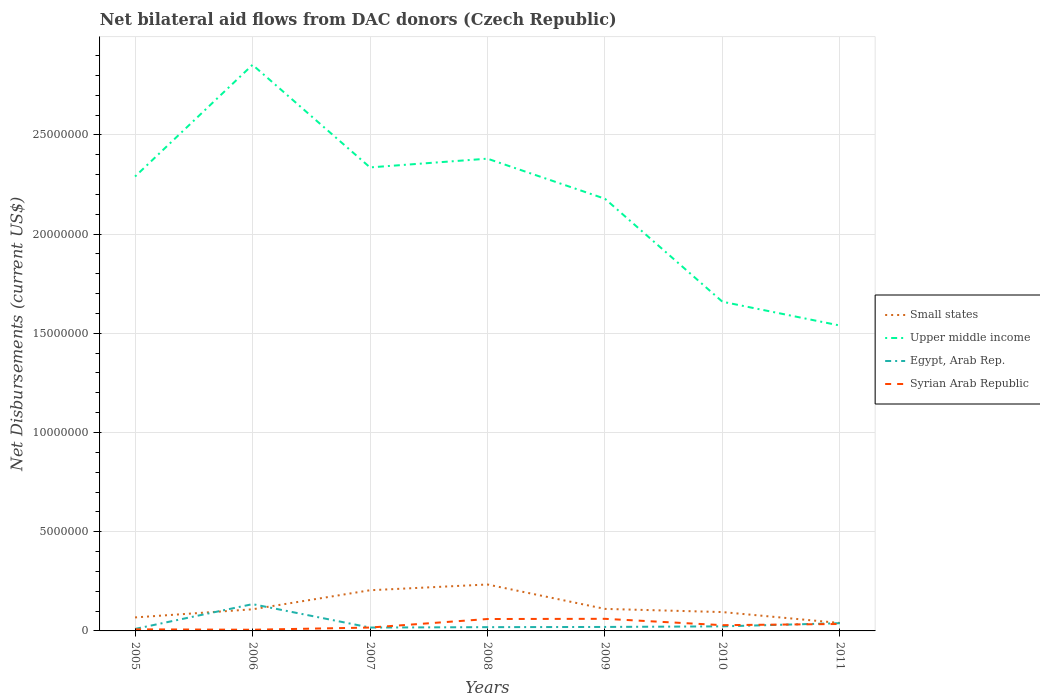Is the number of lines equal to the number of legend labels?
Ensure brevity in your answer.  Yes. Across all years, what is the maximum net bilateral aid flows in Upper middle income?
Give a very brief answer. 1.54e+07. What is the total net bilateral aid flows in Syrian Arab Republic in the graph?
Provide a short and direct response. -1.10e+05. What is the difference between the highest and the second highest net bilateral aid flows in Small states?
Your answer should be very brief. 1.94e+06. What is the difference between the highest and the lowest net bilateral aid flows in Egypt, Arab Rep.?
Keep it short and to the point. 2. Is the net bilateral aid flows in Syrian Arab Republic strictly greater than the net bilateral aid flows in Egypt, Arab Rep. over the years?
Keep it short and to the point. No. How many lines are there?
Offer a very short reply. 4. What is the difference between two consecutive major ticks on the Y-axis?
Offer a very short reply. 5.00e+06. Does the graph contain any zero values?
Your response must be concise. No. Does the graph contain grids?
Ensure brevity in your answer.  Yes. Where does the legend appear in the graph?
Give a very brief answer. Center right. How many legend labels are there?
Give a very brief answer. 4. What is the title of the graph?
Offer a very short reply. Net bilateral aid flows from DAC donors (Czech Republic). What is the label or title of the X-axis?
Provide a succinct answer. Years. What is the label or title of the Y-axis?
Your response must be concise. Net Disbursements (current US$). What is the Net Disbursements (current US$) of Small states in 2005?
Your answer should be compact. 6.80e+05. What is the Net Disbursements (current US$) of Upper middle income in 2005?
Offer a terse response. 2.29e+07. What is the Net Disbursements (current US$) of Syrian Arab Republic in 2005?
Offer a very short reply. 8.00e+04. What is the Net Disbursements (current US$) in Small states in 2006?
Offer a terse response. 1.09e+06. What is the Net Disbursements (current US$) of Upper middle income in 2006?
Your response must be concise. 2.85e+07. What is the Net Disbursements (current US$) in Egypt, Arab Rep. in 2006?
Your answer should be very brief. 1.35e+06. What is the Net Disbursements (current US$) of Small states in 2007?
Your answer should be very brief. 2.05e+06. What is the Net Disbursements (current US$) of Upper middle income in 2007?
Your answer should be very brief. 2.34e+07. What is the Net Disbursements (current US$) of Egypt, Arab Rep. in 2007?
Make the answer very short. 1.70e+05. What is the Net Disbursements (current US$) in Syrian Arab Republic in 2007?
Offer a very short reply. 1.70e+05. What is the Net Disbursements (current US$) in Small states in 2008?
Your answer should be very brief. 2.34e+06. What is the Net Disbursements (current US$) of Upper middle income in 2008?
Your answer should be compact. 2.38e+07. What is the Net Disbursements (current US$) in Syrian Arab Republic in 2008?
Your answer should be very brief. 6.00e+05. What is the Net Disbursements (current US$) of Small states in 2009?
Offer a terse response. 1.11e+06. What is the Net Disbursements (current US$) of Upper middle income in 2009?
Offer a very short reply. 2.18e+07. What is the Net Disbursements (current US$) of Egypt, Arab Rep. in 2009?
Your answer should be very brief. 2.00e+05. What is the Net Disbursements (current US$) in Small states in 2010?
Your response must be concise. 9.50e+05. What is the Net Disbursements (current US$) in Upper middle income in 2010?
Make the answer very short. 1.66e+07. What is the Net Disbursements (current US$) in Egypt, Arab Rep. in 2010?
Ensure brevity in your answer.  2.30e+05. What is the Net Disbursements (current US$) of Syrian Arab Republic in 2010?
Your answer should be very brief. 2.90e+05. What is the Net Disbursements (current US$) of Upper middle income in 2011?
Offer a very short reply. 1.54e+07. What is the Net Disbursements (current US$) of Egypt, Arab Rep. in 2011?
Keep it short and to the point. 3.90e+05. Across all years, what is the maximum Net Disbursements (current US$) in Small states?
Provide a short and direct response. 2.34e+06. Across all years, what is the maximum Net Disbursements (current US$) in Upper middle income?
Your answer should be compact. 2.85e+07. Across all years, what is the maximum Net Disbursements (current US$) in Egypt, Arab Rep.?
Provide a succinct answer. 1.35e+06. Across all years, what is the minimum Net Disbursements (current US$) in Upper middle income?
Provide a short and direct response. 1.54e+07. Across all years, what is the minimum Net Disbursements (current US$) in Syrian Arab Republic?
Offer a very short reply. 6.00e+04. What is the total Net Disbursements (current US$) in Small states in the graph?
Give a very brief answer. 8.62e+06. What is the total Net Disbursements (current US$) of Upper middle income in the graph?
Make the answer very short. 1.52e+08. What is the total Net Disbursements (current US$) of Egypt, Arab Rep. in the graph?
Offer a terse response. 2.63e+06. What is the total Net Disbursements (current US$) of Syrian Arab Republic in the graph?
Make the answer very short. 2.16e+06. What is the difference between the Net Disbursements (current US$) in Small states in 2005 and that in 2006?
Provide a short and direct response. -4.10e+05. What is the difference between the Net Disbursements (current US$) in Upper middle income in 2005 and that in 2006?
Your answer should be compact. -5.63e+06. What is the difference between the Net Disbursements (current US$) in Egypt, Arab Rep. in 2005 and that in 2006?
Offer a very short reply. -1.25e+06. What is the difference between the Net Disbursements (current US$) of Syrian Arab Republic in 2005 and that in 2006?
Ensure brevity in your answer.  2.00e+04. What is the difference between the Net Disbursements (current US$) of Small states in 2005 and that in 2007?
Provide a succinct answer. -1.37e+06. What is the difference between the Net Disbursements (current US$) of Upper middle income in 2005 and that in 2007?
Keep it short and to the point. -4.60e+05. What is the difference between the Net Disbursements (current US$) in Small states in 2005 and that in 2008?
Keep it short and to the point. -1.66e+06. What is the difference between the Net Disbursements (current US$) in Upper middle income in 2005 and that in 2008?
Give a very brief answer. -9.00e+05. What is the difference between the Net Disbursements (current US$) of Egypt, Arab Rep. in 2005 and that in 2008?
Keep it short and to the point. -9.00e+04. What is the difference between the Net Disbursements (current US$) of Syrian Arab Republic in 2005 and that in 2008?
Give a very brief answer. -5.20e+05. What is the difference between the Net Disbursements (current US$) of Small states in 2005 and that in 2009?
Provide a succinct answer. -4.30e+05. What is the difference between the Net Disbursements (current US$) of Upper middle income in 2005 and that in 2009?
Provide a succinct answer. 1.12e+06. What is the difference between the Net Disbursements (current US$) in Egypt, Arab Rep. in 2005 and that in 2009?
Ensure brevity in your answer.  -1.00e+05. What is the difference between the Net Disbursements (current US$) in Syrian Arab Republic in 2005 and that in 2009?
Offer a very short reply. -5.30e+05. What is the difference between the Net Disbursements (current US$) of Small states in 2005 and that in 2010?
Your response must be concise. -2.70e+05. What is the difference between the Net Disbursements (current US$) of Upper middle income in 2005 and that in 2010?
Make the answer very short. 6.31e+06. What is the difference between the Net Disbursements (current US$) in Upper middle income in 2005 and that in 2011?
Your answer should be compact. 7.51e+06. What is the difference between the Net Disbursements (current US$) in Egypt, Arab Rep. in 2005 and that in 2011?
Give a very brief answer. -2.90e+05. What is the difference between the Net Disbursements (current US$) of Syrian Arab Republic in 2005 and that in 2011?
Your answer should be very brief. -2.70e+05. What is the difference between the Net Disbursements (current US$) of Small states in 2006 and that in 2007?
Make the answer very short. -9.60e+05. What is the difference between the Net Disbursements (current US$) in Upper middle income in 2006 and that in 2007?
Provide a short and direct response. 5.17e+06. What is the difference between the Net Disbursements (current US$) in Egypt, Arab Rep. in 2006 and that in 2007?
Offer a very short reply. 1.18e+06. What is the difference between the Net Disbursements (current US$) of Small states in 2006 and that in 2008?
Provide a short and direct response. -1.25e+06. What is the difference between the Net Disbursements (current US$) in Upper middle income in 2006 and that in 2008?
Offer a very short reply. 4.73e+06. What is the difference between the Net Disbursements (current US$) of Egypt, Arab Rep. in 2006 and that in 2008?
Keep it short and to the point. 1.16e+06. What is the difference between the Net Disbursements (current US$) of Syrian Arab Republic in 2006 and that in 2008?
Provide a succinct answer. -5.40e+05. What is the difference between the Net Disbursements (current US$) in Small states in 2006 and that in 2009?
Your answer should be very brief. -2.00e+04. What is the difference between the Net Disbursements (current US$) of Upper middle income in 2006 and that in 2009?
Ensure brevity in your answer.  6.75e+06. What is the difference between the Net Disbursements (current US$) of Egypt, Arab Rep. in 2006 and that in 2009?
Offer a terse response. 1.15e+06. What is the difference between the Net Disbursements (current US$) of Syrian Arab Republic in 2006 and that in 2009?
Your answer should be compact. -5.50e+05. What is the difference between the Net Disbursements (current US$) in Small states in 2006 and that in 2010?
Your answer should be very brief. 1.40e+05. What is the difference between the Net Disbursements (current US$) in Upper middle income in 2006 and that in 2010?
Your response must be concise. 1.19e+07. What is the difference between the Net Disbursements (current US$) in Egypt, Arab Rep. in 2006 and that in 2010?
Provide a short and direct response. 1.12e+06. What is the difference between the Net Disbursements (current US$) of Syrian Arab Republic in 2006 and that in 2010?
Offer a very short reply. -2.30e+05. What is the difference between the Net Disbursements (current US$) in Small states in 2006 and that in 2011?
Offer a terse response. 6.90e+05. What is the difference between the Net Disbursements (current US$) in Upper middle income in 2006 and that in 2011?
Give a very brief answer. 1.31e+07. What is the difference between the Net Disbursements (current US$) of Egypt, Arab Rep. in 2006 and that in 2011?
Provide a short and direct response. 9.60e+05. What is the difference between the Net Disbursements (current US$) of Syrian Arab Republic in 2006 and that in 2011?
Your response must be concise. -2.90e+05. What is the difference between the Net Disbursements (current US$) of Small states in 2007 and that in 2008?
Keep it short and to the point. -2.90e+05. What is the difference between the Net Disbursements (current US$) in Upper middle income in 2007 and that in 2008?
Ensure brevity in your answer.  -4.40e+05. What is the difference between the Net Disbursements (current US$) of Syrian Arab Republic in 2007 and that in 2008?
Keep it short and to the point. -4.30e+05. What is the difference between the Net Disbursements (current US$) of Small states in 2007 and that in 2009?
Make the answer very short. 9.40e+05. What is the difference between the Net Disbursements (current US$) in Upper middle income in 2007 and that in 2009?
Your response must be concise. 1.58e+06. What is the difference between the Net Disbursements (current US$) in Egypt, Arab Rep. in 2007 and that in 2009?
Provide a succinct answer. -3.00e+04. What is the difference between the Net Disbursements (current US$) in Syrian Arab Republic in 2007 and that in 2009?
Make the answer very short. -4.40e+05. What is the difference between the Net Disbursements (current US$) in Small states in 2007 and that in 2010?
Give a very brief answer. 1.10e+06. What is the difference between the Net Disbursements (current US$) in Upper middle income in 2007 and that in 2010?
Keep it short and to the point. 6.77e+06. What is the difference between the Net Disbursements (current US$) of Egypt, Arab Rep. in 2007 and that in 2010?
Keep it short and to the point. -6.00e+04. What is the difference between the Net Disbursements (current US$) of Small states in 2007 and that in 2011?
Provide a short and direct response. 1.65e+06. What is the difference between the Net Disbursements (current US$) of Upper middle income in 2007 and that in 2011?
Your answer should be compact. 7.97e+06. What is the difference between the Net Disbursements (current US$) in Egypt, Arab Rep. in 2007 and that in 2011?
Keep it short and to the point. -2.20e+05. What is the difference between the Net Disbursements (current US$) of Syrian Arab Republic in 2007 and that in 2011?
Ensure brevity in your answer.  -1.80e+05. What is the difference between the Net Disbursements (current US$) in Small states in 2008 and that in 2009?
Give a very brief answer. 1.23e+06. What is the difference between the Net Disbursements (current US$) in Upper middle income in 2008 and that in 2009?
Your answer should be very brief. 2.02e+06. What is the difference between the Net Disbursements (current US$) of Syrian Arab Republic in 2008 and that in 2009?
Your answer should be very brief. -10000. What is the difference between the Net Disbursements (current US$) of Small states in 2008 and that in 2010?
Your answer should be very brief. 1.39e+06. What is the difference between the Net Disbursements (current US$) in Upper middle income in 2008 and that in 2010?
Your response must be concise. 7.21e+06. What is the difference between the Net Disbursements (current US$) of Egypt, Arab Rep. in 2008 and that in 2010?
Give a very brief answer. -4.00e+04. What is the difference between the Net Disbursements (current US$) in Small states in 2008 and that in 2011?
Your answer should be compact. 1.94e+06. What is the difference between the Net Disbursements (current US$) in Upper middle income in 2008 and that in 2011?
Provide a short and direct response. 8.41e+06. What is the difference between the Net Disbursements (current US$) in Upper middle income in 2009 and that in 2010?
Give a very brief answer. 5.19e+06. What is the difference between the Net Disbursements (current US$) of Small states in 2009 and that in 2011?
Provide a succinct answer. 7.10e+05. What is the difference between the Net Disbursements (current US$) in Upper middle income in 2009 and that in 2011?
Your answer should be very brief. 6.39e+06. What is the difference between the Net Disbursements (current US$) in Small states in 2010 and that in 2011?
Your answer should be compact. 5.50e+05. What is the difference between the Net Disbursements (current US$) of Upper middle income in 2010 and that in 2011?
Give a very brief answer. 1.20e+06. What is the difference between the Net Disbursements (current US$) in Small states in 2005 and the Net Disbursements (current US$) in Upper middle income in 2006?
Provide a short and direct response. -2.78e+07. What is the difference between the Net Disbursements (current US$) in Small states in 2005 and the Net Disbursements (current US$) in Egypt, Arab Rep. in 2006?
Make the answer very short. -6.70e+05. What is the difference between the Net Disbursements (current US$) of Small states in 2005 and the Net Disbursements (current US$) of Syrian Arab Republic in 2006?
Make the answer very short. 6.20e+05. What is the difference between the Net Disbursements (current US$) in Upper middle income in 2005 and the Net Disbursements (current US$) in Egypt, Arab Rep. in 2006?
Your answer should be compact. 2.16e+07. What is the difference between the Net Disbursements (current US$) in Upper middle income in 2005 and the Net Disbursements (current US$) in Syrian Arab Republic in 2006?
Offer a terse response. 2.28e+07. What is the difference between the Net Disbursements (current US$) in Egypt, Arab Rep. in 2005 and the Net Disbursements (current US$) in Syrian Arab Republic in 2006?
Offer a terse response. 4.00e+04. What is the difference between the Net Disbursements (current US$) of Small states in 2005 and the Net Disbursements (current US$) of Upper middle income in 2007?
Provide a short and direct response. -2.27e+07. What is the difference between the Net Disbursements (current US$) of Small states in 2005 and the Net Disbursements (current US$) of Egypt, Arab Rep. in 2007?
Your answer should be very brief. 5.10e+05. What is the difference between the Net Disbursements (current US$) in Small states in 2005 and the Net Disbursements (current US$) in Syrian Arab Republic in 2007?
Ensure brevity in your answer.  5.10e+05. What is the difference between the Net Disbursements (current US$) of Upper middle income in 2005 and the Net Disbursements (current US$) of Egypt, Arab Rep. in 2007?
Your answer should be compact. 2.27e+07. What is the difference between the Net Disbursements (current US$) of Upper middle income in 2005 and the Net Disbursements (current US$) of Syrian Arab Republic in 2007?
Give a very brief answer. 2.27e+07. What is the difference between the Net Disbursements (current US$) of Egypt, Arab Rep. in 2005 and the Net Disbursements (current US$) of Syrian Arab Republic in 2007?
Give a very brief answer. -7.00e+04. What is the difference between the Net Disbursements (current US$) of Small states in 2005 and the Net Disbursements (current US$) of Upper middle income in 2008?
Make the answer very short. -2.31e+07. What is the difference between the Net Disbursements (current US$) of Small states in 2005 and the Net Disbursements (current US$) of Egypt, Arab Rep. in 2008?
Keep it short and to the point. 4.90e+05. What is the difference between the Net Disbursements (current US$) in Upper middle income in 2005 and the Net Disbursements (current US$) in Egypt, Arab Rep. in 2008?
Ensure brevity in your answer.  2.27e+07. What is the difference between the Net Disbursements (current US$) in Upper middle income in 2005 and the Net Disbursements (current US$) in Syrian Arab Republic in 2008?
Provide a succinct answer. 2.23e+07. What is the difference between the Net Disbursements (current US$) of Egypt, Arab Rep. in 2005 and the Net Disbursements (current US$) of Syrian Arab Republic in 2008?
Make the answer very short. -5.00e+05. What is the difference between the Net Disbursements (current US$) in Small states in 2005 and the Net Disbursements (current US$) in Upper middle income in 2009?
Offer a terse response. -2.11e+07. What is the difference between the Net Disbursements (current US$) in Small states in 2005 and the Net Disbursements (current US$) in Syrian Arab Republic in 2009?
Provide a short and direct response. 7.00e+04. What is the difference between the Net Disbursements (current US$) in Upper middle income in 2005 and the Net Disbursements (current US$) in Egypt, Arab Rep. in 2009?
Give a very brief answer. 2.27e+07. What is the difference between the Net Disbursements (current US$) of Upper middle income in 2005 and the Net Disbursements (current US$) of Syrian Arab Republic in 2009?
Provide a succinct answer. 2.23e+07. What is the difference between the Net Disbursements (current US$) in Egypt, Arab Rep. in 2005 and the Net Disbursements (current US$) in Syrian Arab Republic in 2009?
Offer a very short reply. -5.10e+05. What is the difference between the Net Disbursements (current US$) in Small states in 2005 and the Net Disbursements (current US$) in Upper middle income in 2010?
Offer a very short reply. -1.59e+07. What is the difference between the Net Disbursements (current US$) of Upper middle income in 2005 and the Net Disbursements (current US$) of Egypt, Arab Rep. in 2010?
Offer a very short reply. 2.27e+07. What is the difference between the Net Disbursements (current US$) in Upper middle income in 2005 and the Net Disbursements (current US$) in Syrian Arab Republic in 2010?
Make the answer very short. 2.26e+07. What is the difference between the Net Disbursements (current US$) in Small states in 2005 and the Net Disbursements (current US$) in Upper middle income in 2011?
Provide a succinct answer. -1.47e+07. What is the difference between the Net Disbursements (current US$) of Small states in 2005 and the Net Disbursements (current US$) of Egypt, Arab Rep. in 2011?
Provide a succinct answer. 2.90e+05. What is the difference between the Net Disbursements (current US$) in Small states in 2005 and the Net Disbursements (current US$) in Syrian Arab Republic in 2011?
Your response must be concise. 3.30e+05. What is the difference between the Net Disbursements (current US$) of Upper middle income in 2005 and the Net Disbursements (current US$) of Egypt, Arab Rep. in 2011?
Offer a terse response. 2.25e+07. What is the difference between the Net Disbursements (current US$) in Upper middle income in 2005 and the Net Disbursements (current US$) in Syrian Arab Republic in 2011?
Your response must be concise. 2.26e+07. What is the difference between the Net Disbursements (current US$) in Egypt, Arab Rep. in 2005 and the Net Disbursements (current US$) in Syrian Arab Republic in 2011?
Provide a succinct answer. -2.50e+05. What is the difference between the Net Disbursements (current US$) of Small states in 2006 and the Net Disbursements (current US$) of Upper middle income in 2007?
Make the answer very short. -2.23e+07. What is the difference between the Net Disbursements (current US$) in Small states in 2006 and the Net Disbursements (current US$) in Egypt, Arab Rep. in 2007?
Give a very brief answer. 9.20e+05. What is the difference between the Net Disbursements (current US$) in Small states in 2006 and the Net Disbursements (current US$) in Syrian Arab Republic in 2007?
Give a very brief answer. 9.20e+05. What is the difference between the Net Disbursements (current US$) of Upper middle income in 2006 and the Net Disbursements (current US$) of Egypt, Arab Rep. in 2007?
Provide a succinct answer. 2.84e+07. What is the difference between the Net Disbursements (current US$) of Upper middle income in 2006 and the Net Disbursements (current US$) of Syrian Arab Republic in 2007?
Offer a very short reply. 2.84e+07. What is the difference between the Net Disbursements (current US$) of Egypt, Arab Rep. in 2006 and the Net Disbursements (current US$) of Syrian Arab Republic in 2007?
Your answer should be compact. 1.18e+06. What is the difference between the Net Disbursements (current US$) in Small states in 2006 and the Net Disbursements (current US$) in Upper middle income in 2008?
Your answer should be compact. -2.27e+07. What is the difference between the Net Disbursements (current US$) in Small states in 2006 and the Net Disbursements (current US$) in Egypt, Arab Rep. in 2008?
Keep it short and to the point. 9.00e+05. What is the difference between the Net Disbursements (current US$) of Upper middle income in 2006 and the Net Disbursements (current US$) of Egypt, Arab Rep. in 2008?
Your answer should be compact. 2.83e+07. What is the difference between the Net Disbursements (current US$) in Upper middle income in 2006 and the Net Disbursements (current US$) in Syrian Arab Republic in 2008?
Provide a short and direct response. 2.79e+07. What is the difference between the Net Disbursements (current US$) in Egypt, Arab Rep. in 2006 and the Net Disbursements (current US$) in Syrian Arab Republic in 2008?
Give a very brief answer. 7.50e+05. What is the difference between the Net Disbursements (current US$) of Small states in 2006 and the Net Disbursements (current US$) of Upper middle income in 2009?
Your answer should be compact. -2.07e+07. What is the difference between the Net Disbursements (current US$) in Small states in 2006 and the Net Disbursements (current US$) in Egypt, Arab Rep. in 2009?
Give a very brief answer. 8.90e+05. What is the difference between the Net Disbursements (current US$) in Upper middle income in 2006 and the Net Disbursements (current US$) in Egypt, Arab Rep. in 2009?
Provide a succinct answer. 2.83e+07. What is the difference between the Net Disbursements (current US$) of Upper middle income in 2006 and the Net Disbursements (current US$) of Syrian Arab Republic in 2009?
Give a very brief answer. 2.79e+07. What is the difference between the Net Disbursements (current US$) of Egypt, Arab Rep. in 2006 and the Net Disbursements (current US$) of Syrian Arab Republic in 2009?
Give a very brief answer. 7.40e+05. What is the difference between the Net Disbursements (current US$) in Small states in 2006 and the Net Disbursements (current US$) in Upper middle income in 2010?
Provide a succinct answer. -1.55e+07. What is the difference between the Net Disbursements (current US$) in Small states in 2006 and the Net Disbursements (current US$) in Egypt, Arab Rep. in 2010?
Ensure brevity in your answer.  8.60e+05. What is the difference between the Net Disbursements (current US$) in Upper middle income in 2006 and the Net Disbursements (current US$) in Egypt, Arab Rep. in 2010?
Give a very brief answer. 2.83e+07. What is the difference between the Net Disbursements (current US$) in Upper middle income in 2006 and the Net Disbursements (current US$) in Syrian Arab Republic in 2010?
Your answer should be compact. 2.82e+07. What is the difference between the Net Disbursements (current US$) of Egypt, Arab Rep. in 2006 and the Net Disbursements (current US$) of Syrian Arab Republic in 2010?
Keep it short and to the point. 1.06e+06. What is the difference between the Net Disbursements (current US$) of Small states in 2006 and the Net Disbursements (current US$) of Upper middle income in 2011?
Keep it short and to the point. -1.43e+07. What is the difference between the Net Disbursements (current US$) in Small states in 2006 and the Net Disbursements (current US$) in Syrian Arab Republic in 2011?
Make the answer very short. 7.40e+05. What is the difference between the Net Disbursements (current US$) of Upper middle income in 2006 and the Net Disbursements (current US$) of Egypt, Arab Rep. in 2011?
Ensure brevity in your answer.  2.81e+07. What is the difference between the Net Disbursements (current US$) of Upper middle income in 2006 and the Net Disbursements (current US$) of Syrian Arab Republic in 2011?
Your answer should be very brief. 2.82e+07. What is the difference between the Net Disbursements (current US$) in Small states in 2007 and the Net Disbursements (current US$) in Upper middle income in 2008?
Provide a short and direct response. -2.18e+07. What is the difference between the Net Disbursements (current US$) of Small states in 2007 and the Net Disbursements (current US$) of Egypt, Arab Rep. in 2008?
Ensure brevity in your answer.  1.86e+06. What is the difference between the Net Disbursements (current US$) of Small states in 2007 and the Net Disbursements (current US$) of Syrian Arab Republic in 2008?
Offer a terse response. 1.45e+06. What is the difference between the Net Disbursements (current US$) in Upper middle income in 2007 and the Net Disbursements (current US$) in Egypt, Arab Rep. in 2008?
Provide a short and direct response. 2.32e+07. What is the difference between the Net Disbursements (current US$) of Upper middle income in 2007 and the Net Disbursements (current US$) of Syrian Arab Republic in 2008?
Make the answer very short. 2.28e+07. What is the difference between the Net Disbursements (current US$) in Egypt, Arab Rep. in 2007 and the Net Disbursements (current US$) in Syrian Arab Republic in 2008?
Keep it short and to the point. -4.30e+05. What is the difference between the Net Disbursements (current US$) in Small states in 2007 and the Net Disbursements (current US$) in Upper middle income in 2009?
Make the answer very short. -1.97e+07. What is the difference between the Net Disbursements (current US$) of Small states in 2007 and the Net Disbursements (current US$) of Egypt, Arab Rep. in 2009?
Your response must be concise. 1.85e+06. What is the difference between the Net Disbursements (current US$) in Small states in 2007 and the Net Disbursements (current US$) in Syrian Arab Republic in 2009?
Offer a very short reply. 1.44e+06. What is the difference between the Net Disbursements (current US$) in Upper middle income in 2007 and the Net Disbursements (current US$) in Egypt, Arab Rep. in 2009?
Provide a succinct answer. 2.32e+07. What is the difference between the Net Disbursements (current US$) in Upper middle income in 2007 and the Net Disbursements (current US$) in Syrian Arab Republic in 2009?
Your answer should be compact. 2.28e+07. What is the difference between the Net Disbursements (current US$) of Egypt, Arab Rep. in 2007 and the Net Disbursements (current US$) of Syrian Arab Republic in 2009?
Your response must be concise. -4.40e+05. What is the difference between the Net Disbursements (current US$) of Small states in 2007 and the Net Disbursements (current US$) of Upper middle income in 2010?
Offer a terse response. -1.45e+07. What is the difference between the Net Disbursements (current US$) of Small states in 2007 and the Net Disbursements (current US$) of Egypt, Arab Rep. in 2010?
Your response must be concise. 1.82e+06. What is the difference between the Net Disbursements (current US$) in Small states in 2007 and the Net Disbursements (current US$) in Syrian Arab Republic in 2010?
Provide a short and direct response. 1.76e+06. What is the difference between the Net Disbursements (current US$) of Upper middle income in 2007 and the Net Disbursements (current US$) of Egypt, Arab Rep. in 2010?
Offer a terse response. 2.31e+07. What is the difference between the Net Disbursements (current US$) in Upper middle income in 2007 and the Net Disbursements (current US$) in Syrian Arab Republic in 2010?
Give a very brief answer. 2.31e+07. What is the difference between the Net Disbursements (current US$) in Small states in 2007 and the Net Disbursements (current US$) in Upper middle income in 2011?
Keep it short and to the point. -1.33e+07. What is the difference between the Net Disbursements (current US$) of Small states in 2007 and the Net Disbursements (current US$) of Egypt, Arab Rep. in 2011?
Give a very brief answer. 1.66e+06. What is the difference between the Net Disbursements (current US$) in Small states in 2007 and the Net Disbursements (current US$) in Syrian Arab Republic in 2011?
Your answer should be compact. 1.70e+06. What is the difference between the Net Disbursements (current US$) in Upper middle income in 2007 and the Net Disbursements (current US$) in Egypt, Arab Rep. in 2011?
Provide a succinct answer. 2.30e+07. What is the difference between the Net Disbursements (current US$) of Upper middle income in 2007 and the Net Disbursements (current US$) of Syrian Arab Republic in 2011?
Offer a terse response. 2.30e+07. What is the difference between the Net Disbursements (current US$) of Egypt, Arab Rep. in 2007 and the Net Disbursements (current US$) of Syrian Arab Republic in 2011?
Provide a short and direct response. -1.80e+05. What is the difference between the Net Disbursements (current US$) in Small states in 2008 and the Net Disbursements (current US$) in Upper middle income in 2009?
Your answer should be compact. -1.94e+07. What is the difference between the Net Disbursements (current US$) in Small states in 2008 and the Net Disbursements (current US$) in Egypt, Arab Rep. in 2009?
Your answer should be very brief. 2.14e+06. What is the difference between the Net Disbursements (current US$) of Small states in 2008 and the Net Disbursements (current US$) of Syrian Arab Republic in 2009?
Offer a terse response. 1.73e+06. What is the difference between the Net Disbursements (current US$) in Upper middle income in 2008 and the Net Disbursements (current US$) in Egypt, Arab Rep. in 2009?
Offer a very short reply. 2.36e+07. What is the difference between the Net Disbursements (current US$) in Upper middle income in 2008 and the Net Disbursements (current US$) in Syrian Arab Republic in 2009?
Your response must be concise. 2.32e+07. What is the difference between the Net Disbursements (current US$) in Egypt, Arab Rep. in 2008 and the Net Disbursements (current US$) in Syrian Arab Republic in 2009?
Ensure brevity in your answer.  -4.20e+05. What is the difference between the Net Disbursements (current US$) of Small states in 2008 and the Net Disbursements (current US$) of Upper middle income in 2010?
Your answer should be very brief. -1.42e+07. What is the difference between the Net Disbursements (current US$) in Small states in 2008 and the Net Disbursements (current US$) in Egypt, Arab Rep. in 2010?
Your response must be concise. 2.11e+06. What is the difference between the Net Disbursements (current US$) in Small states in 2008 and the Net Disbursements (current US$) in Syrian Arab Republic in 2010?
Offer a very short reply. 2.05e+06. What is the difference between the Net Disbursements (current US$) in Upper middle income in 2008 and the Net Disbursements (current US$) in Egypt, Arab Rep. in 2010?
Provide a succinct answer. 2.36e+07. What is the difference between the Net Disbursements (current US$) in Upper middle income in 2008 and the Net Disbursements (current US$) in Syrian Arab Republic in 2010?
Ensure brevity in your answer.  2.35e+07. What is the difference between the Net Disbursements (current US$) in Small states in 2008 and the Net Disbursements (current US$) in Upper middle income in 2011?
Keep it short and to the point. -1.30e+07. What is the difference between the Net Disbursements (current US$) of Small states in 2008 and the Net Disbursements (current US$) of Egypt, Arab Rep. in 2011?
Give a very brief answer. 1.95e+06. What is the difference between the Net Disbursements (current US$) in Small states in 2008 and the Net Disbursements (current US$) in Syrian Arab Republic in 2011?
Offer a very short reply. 1.99e+06. What is the difference between the Net Disbursements (current US$) of Upper middle income in 2008 and the Net Disbursements (current US$) of Egypt, Arab Rep. in 2011?
Your answer should be compact. 2.34e+07. What is the difference between the Net Disbursements (current US$) in Upper middle income in 2008 and the Net Disbursements (current US$) in Syrian Arab Republic in 2011?
Your answer should be very brief. 2.34e+07. What is the difference between the Net Disbursements (current US$) of Egypt, Arab Rep. in 2008 and the Net Disbursements (current US$) of Syrian Arab Republic in 2011?
Give a very brief answer. -1.60e+05. What is the difference between the Net Disbursements (current US$) of Small states in 2009 and the Net Disbursements (current US$) of Upper middle income in 2010?
Your response must be concise. -1.55e+07. What is the difference between the Net Disbursements (current US$) of Small states in 2009 and the Net Disbursements (current US$) of Egypt, Arab Rep. in 2010?
Give a very brief answer. 8.80e+05. What is the difference between the Net Disbursements (current US$) in Small states in 2009 and the Net Disbursements (current US$) in Syrian Arab Republic in 2010?
Offer a very short reply. 8.20e+05. What is the difference between the Net Disbursements (current US$) of Upper middle income in 2009 and the Net Disbursements (current US$) of Egypt, Arab Rep. in 2010?
Make the answer very short. 2.16e+07. What is the difference between the Net Disbursements (current US$) of Upper middle income in 2009 and the Net Disbursements (current US$) of Syrian Arab Republic in 2010?
Provide a succinct answer. 2.15e+07. What is the difference between the Net Disbursements (current US$) of Egypt, Arab Rep. in 2009 and the Net Disbursements (current US$) of Syrian Arab Republic in 2010?
Your response must be concise. -9.00e+04. What is the difference between the Net Disbursements (current US$) of Small states in 2009 and the Net Disbursements (current US$) of Upper middle income in 2011?
Keep it short and to the point. -1.43e+07. What is the difference between the Net Disbursements (current US$) in Small states in 2009 and the Net Disbursements (current US$) in Egypt, Arab Rep. in 2011?
Give a very brief answer. 7.20e+05. What is the difference between the Net Disbursements (current US$) in Small states in 2009 and the Net Disbursements (current US$) in Syrian Arab Republic in 2011?
Give a very brief answer. 7.60e+05. What is the difference between the Net Disbursements (current US$) of Upper middle income in 2009 and the Net Disbursements (current US$) of Egypt, Arab Rep. in 2011?
Provide a succinct answer. 2.14e+07. What is the difference between the Net Disbursements (current US$) in Upper middle income in 2009 and the Net Disbursements (current US$) in Syrian Arab Republic in 2011?
Ensure brevity in your answer.  2.14e+07. What is the difference between the Net Disbursements (current US$) of Egypt, Arab Rep. in 2009 and the Net Disbursements (current US$) of Syrian Arab Republic in 2011?
Provide a short and direct response. -1.50e+05. What is the difference between the Net Disbursements (current US$) in Small states in 2010 and the Net Disbursements (current US$) in Upper middle income in 2011?
Your answer should be very brief. -1.44e+07. What is the difference between the Net Disbursements (current US$) of Small states in 2010 and the Net Disbursements (current US$) of Egypt, Arab Rep. in 2011?
Give a very brief answer. 5.60e+05. What is the difference between the Net Disbursements (current US$) of Small states in 2010 and the Net Disbursements (current US$) of Syrian Arab Republic in 2011?
Keep it short and to the point. 6.00e+05. What is the difference between the Net Disbursements (current US$) of Upper middle income in 2010 and the Net Disbursements (current US$) of Egypt, Arab Rep. in 2011?
Make the answer very short. 1.62e+07. What is the difference between the Net Disbursements (current US$) of Upper middle income in 2010 and the Net Disbursements (current US$) of Syrian Arab Republic in 2011?
Keep it short and to the point. 1.62e+07. What is the difference between the Net Disbursements (current US$) of Egypt, Arab Rep. in 2010 and the Net Disbursements (current US$) of Syrian Arab Republic in 2011?
Offer a terse response. -1.20e+05. What is the average Net Disbursements (current US$) of Small states per year?
Provide a succinct answer. 1.23e+06. What is the average Net Disbursements (current US$) of Upper middle income per year?
Ensure brevity in your answer.  2.18e+07. What is the average Net Disbursements (current US$) in Egypt, Arab Rep. per year?
Ensure brevity in your answer.  3.76e+05. What is the average Net Disbursements (current US$) of Syrian Arab Republic per year?
Give a very brief answer. 3.09e+05. In the year 2005, what is the difference between the Net Disbursements (current US$) in Small states and Net Disbursements (current US$) in Upper middle income?
Your answer should be compact. -2.22e+07. In the year 2005, what is the difference between the Net Disbursements (current US$) of Small states and Net Disbursements (current US$) of Egypt, Arab Rep.?
Provide a short and direct response. 5.80e+05. In the year 2005, what is the difference between the Net Disbursements (current US$) of Upper middle income and Net Disbursements (current US$) of Egypt, Arab Rep.?
Make the answer very short. 2.28e+07. In the year 2005, what is the difference between the Net Disbursements (current US$) of Upper middle income and Net Disbursements (current US$) of Syrian Arab Republic?
Provide a short and direct response. 2.28e+07. In the year 2005, what is the difference between the Net Disbursements (current US$) in Egypt, Arab Rep. and Net Disbursements (current US$) in Syrian Arab Republic?
Make the answer very short. 2.00e+04. In the year 2006, what is the difference between the Net Disbursements (current US$) in Small states and Net Disbursements (current US$) in Upper middle income?
Your answer should be very brief. -2.74e+07. In the year 2006, what is the difference between the Net Disbursements (current US$) in Small states and Net Disbursements (current US$) in Syrian Arab Republic?
Keep it short and to the point. 1.03e+06. In the year 2006, what is the difference between the Net Disbursements (current US$) of Upper middle income and Net Disbursements (current US$) of Egypt, Arab Rep.?
Your response must be concise. 2.72e+07. In the year 2006, what is the difference between the Net Disbursements (current US$) of Upper middle income and Net Disbursements (current US$) of Syrian Arab Republic?
Make the answer very short. 2.85e+07. In the year 2006, what is the difference between the Net Disbursements (current US$) in Egypt, Arab Rep. and Net Disbursements (current US$) in Syrian Arab Republic?
Offer a terse response. 1.29e+06. In the year 2007, what is the difference between the Net Disbursements (current US$) in Small states and Net Disbursements (current US$) in Upper middle income?
Give a very brief answer. -2.13e+07. In the year 2007, what is the difference between the Net Disbursements (current US$) in Small states and Net Disbursements (current US$) in Egypt, Arab Rep.?
Your answer should be compact. 1.88e+06. In the year 2007, what is the difference between the Net Disbursements (current US$) of Small states and Net Disbursements (current US$) of Syrian Arab Republic?
Offer a very short reply. 1.88e+06. In the year 2007, what is the difference between the Net Disbursements (current US$) in Upper middle income and Net Disbursements (current US$) in Egypt, Arab Rep.?
Ensure brevity in your answer.  2.32e+07. In the year 2007, what is the difference between the Net Disbursements (current US$) of Upper middle income and Net Disbursements (current US$) of Syrian Arab Republic?
Give a very brief answer. 2.32e+07. In the year 2007, what is the difference between the Net Disbursements (current US$) of Egypt, Arab Rep. and Net Disbursements (current US$) of Syrian Arab Republic?
Your response must be concise. 0. In the year 2008, what is the difference between the Net Disbursements (current US$) in Small states and Net Disbursements (current US$) in Upper middle income?
Provide a succinct answer. -2.15e+07. In the year 2008, what is the difference between the Net Disbursements (current US$) in Small states and Net Disbursements (current US$) in Egypt, Arab Rep.?
Offer a terse response. 2.15e+06. In the year 2008, what is the difference between the Net Disbursements (current US$) in Small states and Net Disbursements (current US$) in Syrian Arab Republic?
Keep it short and to the point. 1.74e+06. In the year 2008, what is the difference between the Net Disbursements (current US$) in Upper middle income and Net Disbursements (current US$) in Egypt, Arab Rep.?
Make the answer very short. 2.36e+07. In the year 2008, what is the difference between the Net Disbursements (current US$) of Upper middle income and Net Disbursements (current US$) of Syrian Arab Republic?
Provide a short and direct response. 2.32e+07. In the year 2008, what is the difference between the Net Disbursements (current US$) of Egypt, Arab Rep. and Net Disbursements (current US$) of Syrian Arab Republic?
Provide a succinct answer. -4.10e+05. In the year 2009, what is the difference between the Net Disbursements (current US$) of Small states and Net Disbursements (current US$) of Upper middle income?
Your answer should be compact. -2.07e+07. In the year 2009, what is the difference between the Net Disbursements (current US$) of Small states and Net Disbursements (current US$) of Egypt, Arab Rep.?
Offer a very short reply. 9.10e+05. In the year 2009, what is the difference between the Net Disbursements (current US$) in Small states and Net Disbursements (current US$) in Syrian Arab Republic?
Your answer should be compact. 5.00e+05. In the year 2009, what is the difference between the Net Disbursements (current US$) of Upper middle income and Net Disbursements (current US$) of Egypt, Arab Rep.?
Your answer should be compact. 2.16e+07. In the year 2009, what is the difference between the Net Disbursements (current US$) in Upper middle income and Net Disbursements (current US$) in Syrian Arab Republic?
Give a very brief answer. 2.12e+07. In the year 2009, what is the difference between the Net Disbursements (current US$) of Egypt, Arab Rep. and Net Disbursements (current US$) of Syrian Arab Republic?
Your response must be concise. -4.10e+05. In the year 2010, what is the difference between the Net Disbursements (current US$) in Small states and Net Disbursements (current US$) in Upper middle income?
Ensure brevity in your answer.  -1.56e+07. In the year 2010, what is the difference between the Net Disbursements (current US$) in Small states and Net Disbursements (current US$) in Egypt, Arab Rep.?
Your response must be concise. 7.20e+05. In the year 2010, what is the difference between the Net Disbursements (current US$) of Upper middle income and Net Disbursements (current US$) of Egypt, Arab Rep.?
Offer a terse response. 1.64e+07. In the year 2010, what is the difference between the Net Disbursements (current US$) in Upper middle income and Net Disbursements (current US$) in Syrian Arab Republic?
Provide a succinct answer. 1.63e+07. In the year 2011, what is the difference between the Net Disbursements (current US$) in Small states and Net Disbursements (current US$) in Upper middle income?
Your response must be concise. -1.50e+07. In the year 2011, what is the difference between the Net Disbursements (current US$) of Upper middle income and Net Disbursements (current US$) of Egypt, Arab Rep.?
Offer a very short reply. 1.50e+07. In the year 2011, what is the difference between the Net Disbursements (current US$) in Upper middle income and Net Disbursements (current US$) in Syrian Arab Republic?
Provide a short and direct response. 1.50e+07. What is the ratio of the Net Disbursements (current US$) in Small states in 2005 to that in 2006?
Provide a short and direct response. 0.62. What is the ratio of the Net Disbursements (current US$) of Upper middle income in 2005 to that in 2006?
Offer a very short reply. 0.8. What is the ratio of the Net Disbursements (current US$) of Egypt, Arab Rep. in 2005 to that in 2006?
Your response must be concise. 0.07. What is the ratio of the Net Disbursements (current US$) of Small states in 2005 to that in 2007?
Provide a succinct answer. 0.33. What is the ratio of the Net Disbursements (current US$) of Upper middle income in 2005 to that in 2007?
Your answer should be compact. 0.98. What is the ratio of the Net Disbursements (current US$) in Egypt, Arab Rep. in 2005 to that in 2007?
Keep it short and to the point. 0.59. What is the ratio of the Net Disbursements (current US$) of Syrian Arab Republic in 2005 to that in 2007?
Offer a very short reply. 0.47. What is the ratio of the Net Disbursements (current US$) in Small states in 2005 to that in 2008?
Give a very brief answer. 0.29. What is the ratio of the Net Disbursements (current US$) of Upper middle income in 2005 to that in 2008?
Give a very brief answer. 0.96. What is the ratio of the Net Disbursements (current US$) in Egypt, Arab Rep. in 2005 to that in 2008?
Keep it short and to the point. 0.53. What is the ratio of the Net Disbursements (current US$) of Syrian Arab Republic in 2005 to that in 2008?
Give a very brief answer. 0.13. What is the ratio of the Net Disbursements (current US$) in Small states in 2005 to that in 2009?
Your answer should be very brief. 0.61. What is the ratio of the Net Disbursements (current US$) in Upper middle income in 2005 to that in 2009?
Keep it short and to the point. 1.05. What is the ratio of the Net Disbursements (current US$) of Egypt, Arab Rep. in 2005 to that in 2009?
Offer a terse response. 0.5. What is the ratio of the Net Disbursements (current US$) of Syrian Arab Republic in 2005 to that in 2009?
Give a very brief answer. 0.13. What is the ratio of the Net Disbursements (current US$) in Small states in 2005 to that in 2010?
Offer a very short reply. 0.72. What is the ratio of the Net Disbursements (current US$) of Upper middle income in 2005 to that in 2010?
Offer a very short reply. 1.38. What is the ratio of the Net Disbursements (current US$) of Egypt, Arab Rep. in 2005 to that in 2010?
Ensure brevity in your answer.  0.43. What is the ratio of the Net Disbursements (current US$) of Syrian Arab Republic in 2005 to that in 2010?
Give a very brief answer. 0.28. What is the ratio of the Net Disbursements (current US$) of Small states in 2005 to that in 2011?
Offer a very short reply. 1.7. What is the ratio of the Net Disbursements (current US$) in Upper middle income in 2005 to that in 2011?
Offer a very short reply. 1.49. What is the ratio of the Net Disbursements (current US$) of Egypt, Arab Rep. in 2005 to that in 2011?
Make the answer very short. 0.26. What is the ratio of the Net Disbursements (current US$) in Syrian Arab Republic in 2005 to that in 2011?
Your response must be concise. 0.23. What is the ratio of the Net Disbursements (current US$) of Small states in 2006 to that in 2007?
Your answer should be compact. 0.53. What is the ratio of the Net Disbursements (current US$) in Upper middle income in 2006 to that in 2007?
Your answer should be very brief. 1.22. What is the ratio of the Net Disbursements (current US$) in Egypt, Arab Rep. in 2006 to that in 2007?
Your answer should be compact. 7.94. What is the ratio of the Net Disbursements (current US$) in Syrian Arab Republic in 2006 to that in 2007?
Provide a short and direct response. 0.35. What is the ratio of the Net Disbursements (current US$) of Small states in 2006 to that in 2008?
Keep it short and to the point. 0.47. What is the ratio of the Net Disbursements (current US$) in Upper middle income in 2006 to that in 2008?
Provide a short and direct response. 1.2. What is the ratio of the Net Disbursements (current US$) of Egypt, Arab Rep. in 2006 to that in 2008?
Your response must be concise. 7.11. What is the ratio of the Net Disbursements (current US$) in Syrian Arab Republic in 2006 to that in 2008?
Give a very brief answer. 0.1. What is the ratio of the Net Disbursements (current US$) in Upper middle income in 2006 to that in 2009?
Your answer should be compact. 1.31. What is the ratio of the Net Disbursements (current US$) of Egypt, Arab Rep. in 2006 to that in 2009?
Your response must be concise. 6.75. What is the ratio of the Net Disbursements (current US$) in Syrian Arab Republic in 2006 to that in 2009?
Offer a terse response. 0.1. What is the ratio of the Net Disbursements (current US$) in Small states in 2006 to that in 2010?
Keep it short and to the point. 1.15. What is the ratio of the Net Disbursements (current US$) in Upper middle income in 2006 to that in 2010?
Provide a succinct answer. 1.72. What is the ratio of the Net Disbursements (current US$) of Egypt, Arab Rep. in 2006 to that in 2010?
Keep it short and to the point. 5.87. What is the ratio of the Net Disbursements (current US$) of Syrian Arab Republic in 2006 to that in 2010?
Give a very brief answer. 0.21. What is the ratio of the Net Disbursements (current US$) of Small states in 2006 to that in 2011?
Ensure brevity in your answer.  2.73. What is the ratio of the Net Disbursements (current US$) in Upper middle income in 2006 to that in 2011?
Ensure brevity in your answer.  1.85. What is the ratio of the Net Disbursements (current US$) of Egypt, Arab Rep. in 2006 to that in 2011?
Offer a very short reply. 3.46. What is the ratio of the Net Disbursements (current US$) in Syrian Arab Republic in 2006 to that in 2011?
Offer a very short reply. 0.17. What is the ratio of the Net Disbursements (current US$) of Small states in 2007 to that in 2008?
Offer a terse response. 0.88. What is the ratio of the Net Disbursements (current US$) of Upper middle income in 2007 to that in 2008?
Offer a terse response. 0.98. What is the ratio of the Net Disbursements (current US$) of Egypt, Arab Rep. in 2007 to that in 2008?
Offer a very short reply. 0.89. What is the ratio of the Net Disbursements (current US$) of Syrian Arab Republic in 2007 to that in 2008?
Your answer should be compact. 0.28. What is the ratio of the Net Disbursements (current US$) in Small states in 2007 to that in 2009?
Your answer should be compact. 1.85. What is the ratio of the Net Disbursements (current US$) of Upper middle income in 2007 to that in 2009?
Provide a succinct answer. 1.07. What is the ratio of the Net Disbursements (current US$) of Egypt, Arab Rep. in 2007 to that in 2009?
Keep it short and to the point. 0.85. What is the ratio of the Net Disbursements (current US$) of Syrian Arab Republic in 2007 to that in 2009?
Make the answer very short. 0.28. What is the ratio of the Net Disbursements (current US$) of Small states in 2007 to that in 2010?
Your answer should be very brief. 2.16. What is the ratio of the Net Disbursements (current US$) of Upper middle income in 2007 to that in 2010?
Make the answer very short. 1.41. What is the ratio of the Net Disbursements (current US$) in Egypt, Arab Rep. in 2007 to that in 2010?
Provide a short and direct response. 0.74. What is the ratio of the Net Disbursements (current US$) in Syrian Arab Republic in 2007 to that in 2010?
Your answer should be very brief. 0.59. What is the ratio of the Net Disbursements (current US$) in Small states in 2007 to that in 2011?
Provide a succinct answer. 5.12. What is the ratio of the Net Disbursements (current US$) in Upper middle income in 2007 to that in 2011?
Make the answer very short. 1.52. What is the ratio of the Net Disbursements (current US$) of Egypt, Arab Rep. in 2007 to that in 2011?
Provide a succinct answer. 0.44. What is the ratio of the Net Disbursements (current US$) in Syrian Arab Republic in 2007 to that in 2011?
Your answer should be compact. 0.49. What is the ratio of the Net Disbursements (current US$) in Small states in 2008 to that in 2009?
Your response must be concise. 2.11. What is the ratio of the Net Disbursements (current US$) in Upper middle income in 2008 to that in 2009?
Keep it short and to the point. 1.09. What is the ratio of the Net Disbursements (current US$) in Egypt, Arab Rep. in 2008 to that in 2009?
Your response must be concise. 0.95. What is the ratio of the Net Disbursements (current US$) of Syrian Arab Republic in 2008 to that in 2009?
Provide a short and direct response. 0.98. What is the ratio of the Net Disbursements (current US$) in Small states in 2008 to that in 2010?
Offer a terse response. 2.46. What is the ratio of the Net Disbursements (current US$) of Upper middle income in 2008 to that in 2010?
Your response must be concise. 1.43. What is the ratio of the Net Disbursements (current US$) of Egypt, Arab Rep. in 2008 to that in 2010?
Your response must be concise. 0.83. What is the ratio of the Net Disbursements (current US$) of Syrian Arab Republic in 2008 to that in 2010?
Keep it short and to the point. 2.07. What is the ratio of the Net Disbursements (current US$) in Small states in 2008 to that in 2011?
Your response must be concise. 5.85. What is the ratio of the Net Disbursements (current US$) of Upper middle income in 2008 to that in 2011?
Provide a succinct answer. 1.55. What is the ratio of the Net Disbursements (current US$) in Egypt, Arab Rep. in 2008 to that in 2011?
Give a very brief answer. 0.49. What is the ratio of the Net Disbursements (current US$) in Syrian Arab Republic in 2008 to that in 2011?
Provide a short and direct response. 1.71. What is the ratio of the Net Disbursements (current US$) in Small states in 2009 to that in 2010?
Your answer should be compact. 1.17. What is the ratio of the Net Disbursements (current US$) in Upper middle income in 2009 to that in 2010?
Ensure brevity in your answer.  1.31. What is the ratio of the Net Disbursements (current US$) of Egypt, Arab Rep. in 2009 to that in 2010?
Provide a succinct answer. 0.87. What is the ratio of the Net Disbursements (current US$) of Syrian Arab Republic in 2009 to that in 2010?
Your answer should be compact. 2.1. What is the ratio of the Net Disbursements (current US$) in Small states in 2009 to that in 2011?
Make the answer very short. 2.77. What is the ratio of the Net Disbursements (current US$) of Upper middle income in 2009 to that in 2011?
Your answer should be compact. 1.42. What is the ratio of the Net Disbursements (current US$) of Egypt, Arab Rep. in 2009 to that in 2011?
Your answer should be very brief. 0.51. What is the ratio of the Net Disbursements (current US$) of Syrian Arab Republic in 2009 to that in 2011?
Give a very brief answer. 1.74. What is the ratio of the Net Disbursements (current US$) in Small states in 2010 to that in 2011?
Offer a terse response. 2.38. What is the ratio of the Net Disbursements (current US$) of Upper middle income in 2010 to that in 2011?
Your answer should be very brief. 1.08. What is the ratio of the Net Disbursements (current US$) in Egypt, Arab Rep. in 2010 to that in 2011?
Offer a very short reply. 0.59. What is the ratio of the Net Disbursements (current US$) of Syrian Arab Republic in 2010 to that in 2011?
Ensure brevity in your answer.  0.83. What is the difference between the highest and the second highest Net Disbursements (current US$) of Upper middle income?
Ensure brevity in your answer.  4.73e+06. What is the difference between the highest and the second highest Net Disbursements (current US$) of Egypt, Arab Rep.?
Give a very brief answer. 9.60e+05. What is the difference between the highest and the lowest Net Disbursements (current US$) in Small states?
Ensure brevity in your answer.  1.94e+06. What is the difference between the highest and the lowest Net Disbursements (current US$) of Upper middle income?
Give a very brief answer. 1.31e+07. What is the difference between the highest and the lowest Net Disbursements (current US$) in Egypt, Arab Rep.?
Provide a short and direct response. 1.25e+06. 